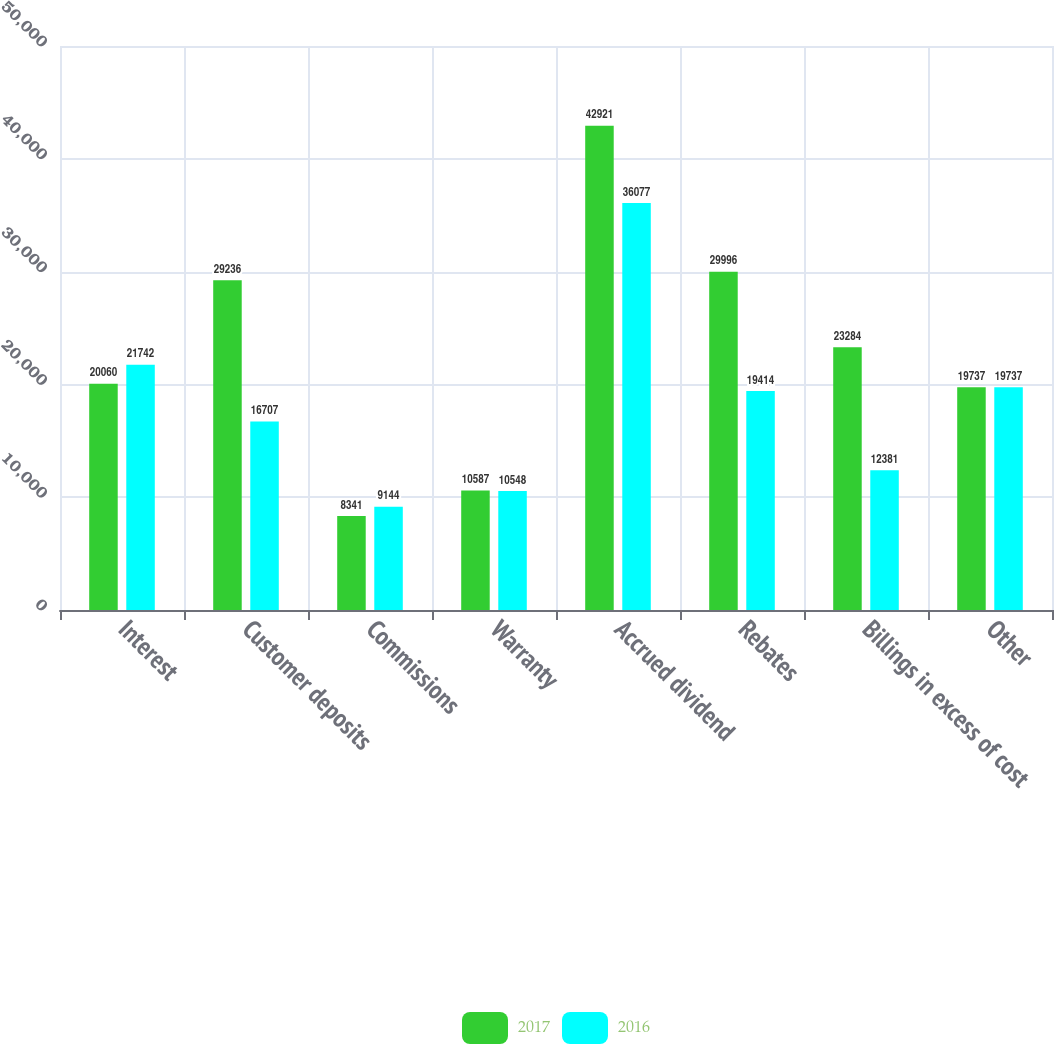<chart> <loc_0><loc_0><loc_500><loc_500><stacked_bar_chart><ecel><fcel>Interest<fcel>Customer deposits<fcel>Commissions<fcel>Warranty<fcel>Accrued dividend<fcel>Rebates<fcel>Billings in excess of cost<fcel>Other<nl><fcel>2017<fcel>20060<fcel>29236<fcel>8341<fcel>10587<fcel>42921<fcel>29996<fcel>23284<fcel>19737<nl><fcel>2016<fcel>21742<fcel>16707<fcel>9144<fcel>10548<fcel>36077<fcel>19414<fcel>12381<fcel>19737<nl></chart> 